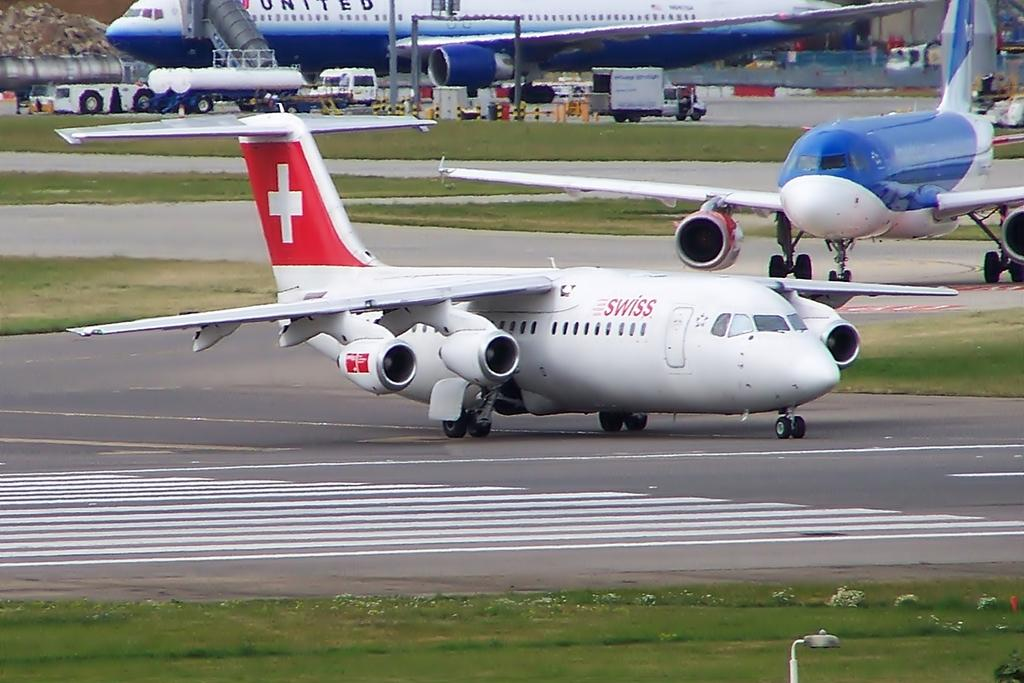Provide a one-sentence caption for the provided image. A white Swiss jet plane on the tarmac with the swiss flag on the tail. 